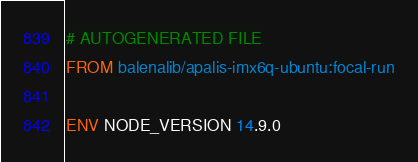<code> <loc_0><loc_0><loc_500><loc_500><_Dockerfile_># AUTOGENERATED FILE
FROM balenalib/apalis-imx6q-ubuntu:focal-run

ENV NODE_VERSION 14.9.0</code> 